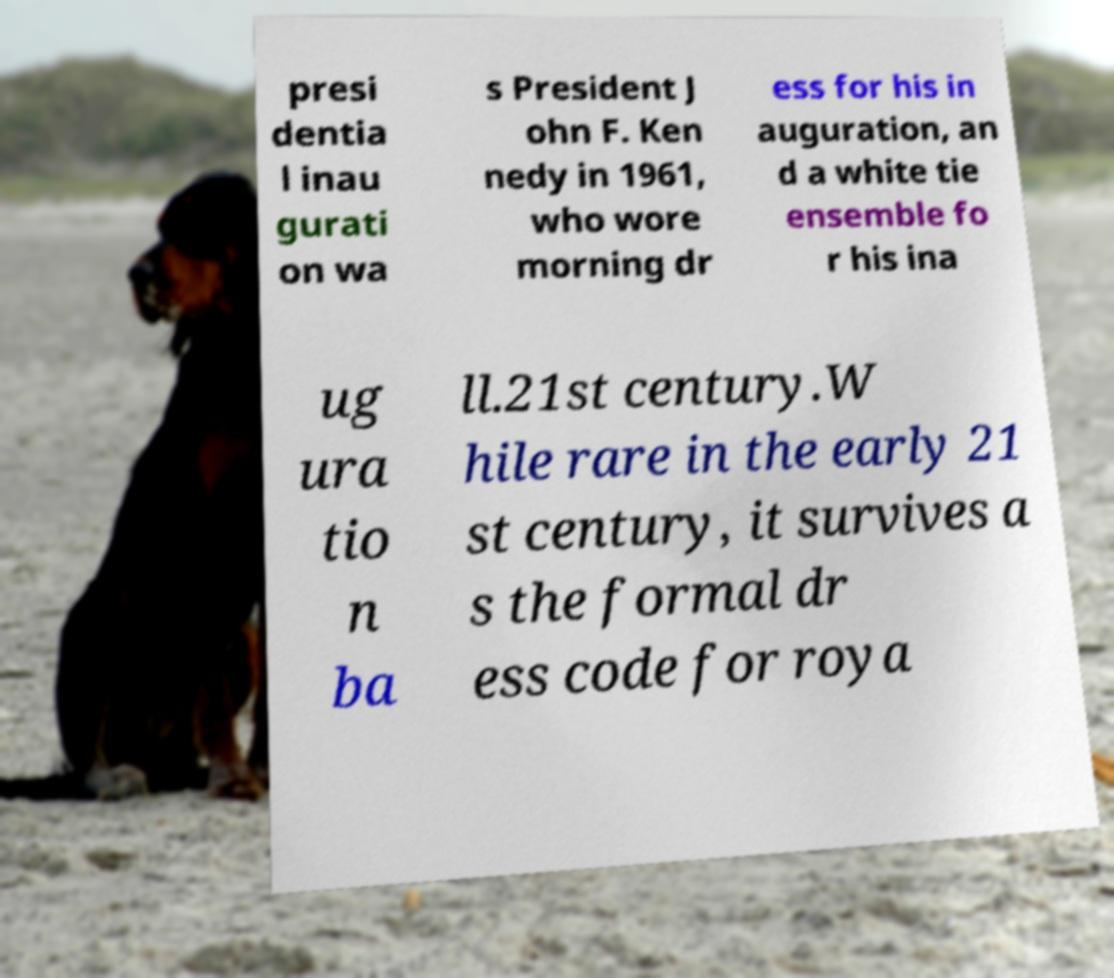Could you extract and type out the text from this image? presi dentia l inau gurati on wa s President J ohn F. Ken nedy in 1961, who wore morning dr ess for his in auguration, an d a white tie ensemble fo r his ina ug ura tio n ba ll.21st century.W hile rare in the early 21 st century, it survives a s the formal dr ess code for roya 